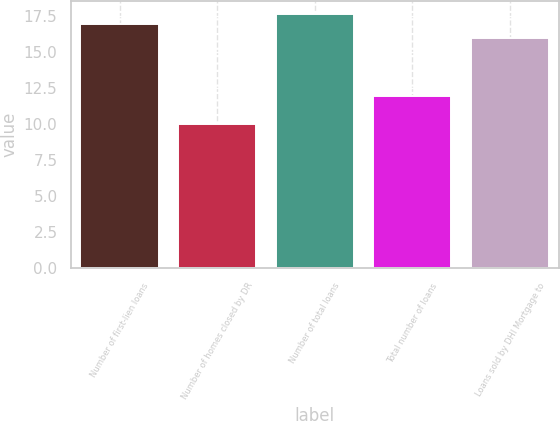<chart> <loc_0><loc_0><loc_500><loc_500><bar_chart><fcel>Number of first-lien loans<fcel>Number of homes closed by DR<fcel>Number of total loans<fcel>Total number of loans<fcel>Loans sold by DHI Mortgage to<nl><fcel>17<fcel>10<fcel>17.7<fcel>12<fcel>16<nl></chart> 